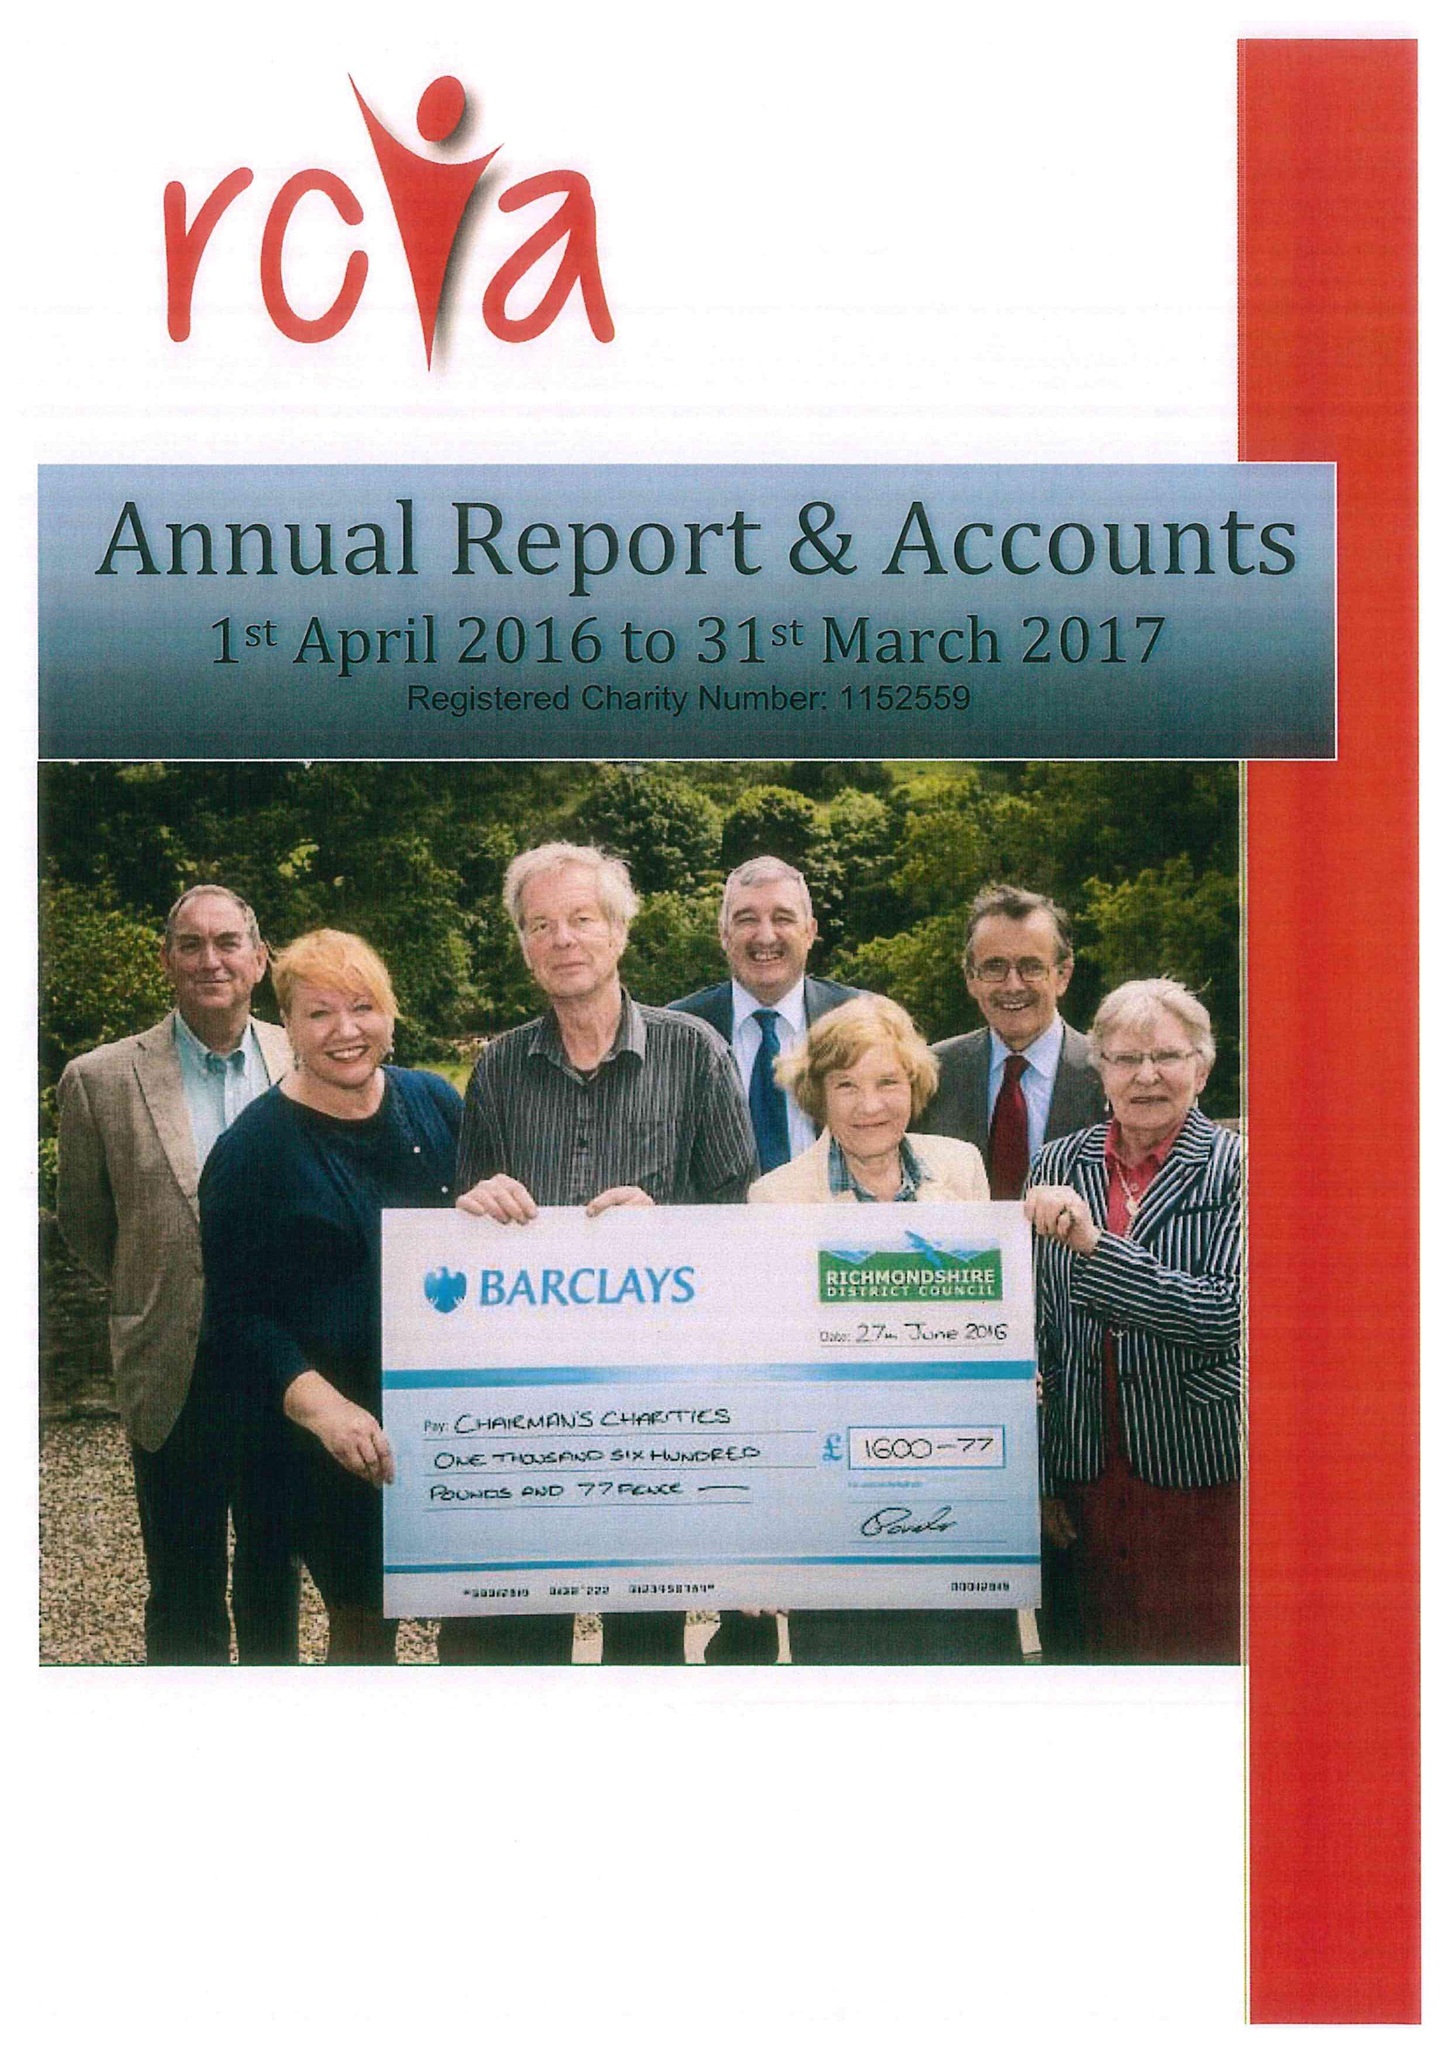What is the value for the charity_number?
Answer the question using a single word or phrase. 1152559 